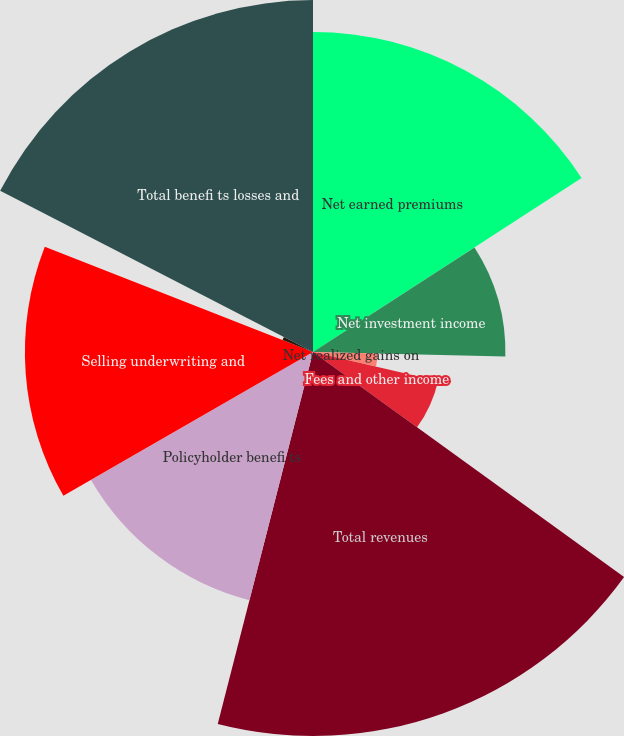Convert chart to OTSL. <chart><loc_0><loc_0><loc_500><loc_500><pie_chart><fcel>Net earned premiums<fcel>Net investment income<fcel>Net realized gains on<fcel>Amortization of deferred gains<fcel>Fees and other income<fcel>Total revenues<fcel>Policyholder benefi ts<fcel>Selling underwriting and<fcel>Interest expense<fcel>Total benefi ts losses and<nl><fcel>15.85%<fcel>9.53%<fcel>3.2%<fcel>0.03%<fcel>6.36%<fcel>19.02%<fcel>12.69%<fcel>14.27%<fcel>1.62%<fcel>17.43%<nl></chart> 